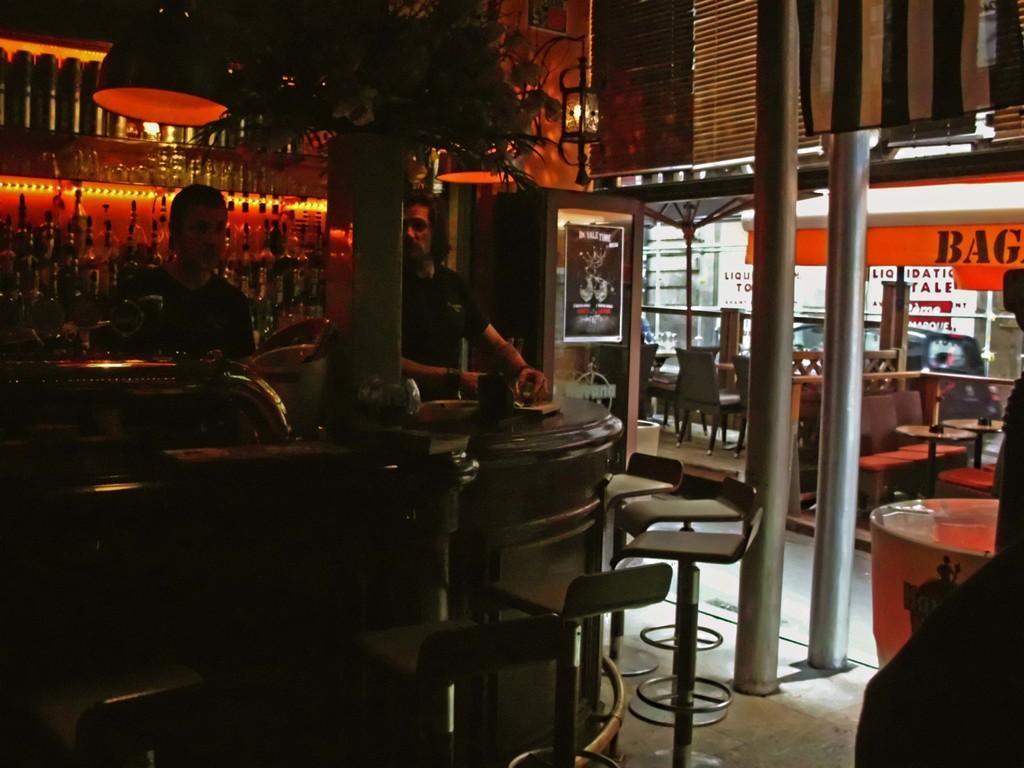Can you describe this image briefly? In this picture we can see two persons are standing in front of them there is a table there are so many chairs are being placed back side of the persons there are so many bottles are arranged in a shelf and right corner we can see so many benches chairs it look like a cafe. 